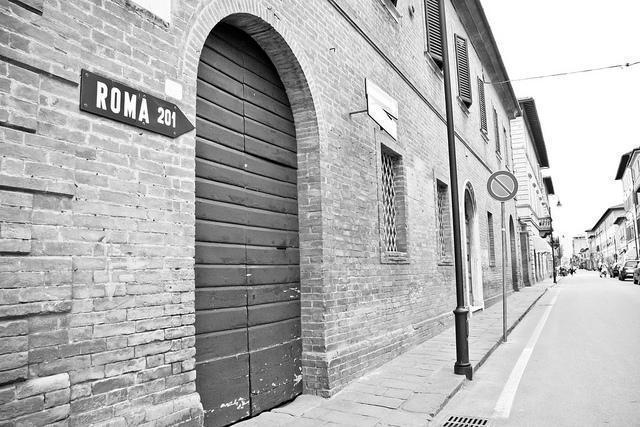What place is this most likely?
Make your selection and explain in format: 'Answer: answer
Rationale: rationale.'
Options: New jersey, new york, rome, china. Answer: rome.
Rationale: That is the italian name for this city. 